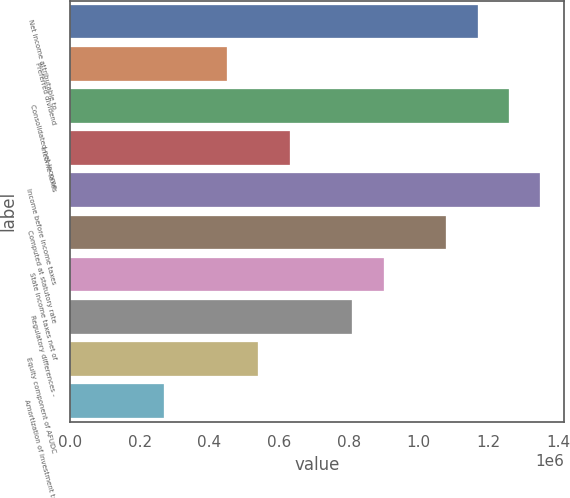Convert chart. <chart><loc_0><loc_0><loc_500><loc_500><bar_chart><fcel>Net income attributable to<fcel>Preferred dividend<fcel>Consolidated net income<fcel>Income taxes<fcel>Income before income taxes<fcel>Computed at statutory rate<fcel>State income taxes net of<fcel>Regulatory differences -<fcel>Equity component of AFUDC<fcel>Amortization of investment tax<nl><fcel>1.16898e+06<fcel>449611<fcel>1.2589e+06<fcel>629454<fcel>1.34883e+06<fcel>1.07906e+06<fcel>899218<fcel>809297<fcel>539532<fcel>269768<nl></chart> 